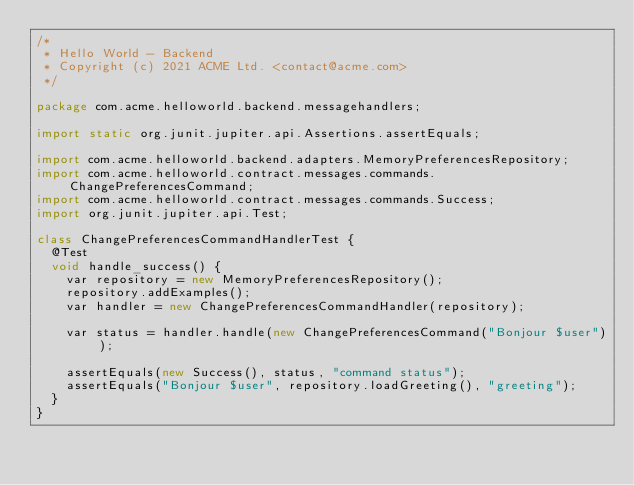<code> <loc_0><loc_0><loc_500><loc_500><_Java_>/*
 * Hello World - Backend
 * Copyright (c) 2021 ACME Ltd. <contact@acme.com>
 */

package com.acme.helloworld.backend.messagehandlers;

import static org.junit.jupiter.api.Assertions.assertEquals;

import com.acme.helloworld.backend.adapters.MemoryPreferencesRepository;
import com.acme.helloworld.contract.messages.commands.ChangePreferencesCommand;
import com.acme.helloworld.contract.messages.commands.Success;
import org.junit.jupiter.api.Test;

class ChangePreferencesCommandHandlerTest {
  @Test
  void handle_success() {
    var repository = new MemoryPreferencesRepository();
    repository.addExamples();
    var handler = new ChangePreferencesCommandHandler(repository);

    var status = handler.handle(new ChangePreferencesCommand("Bonjour $user"));

    assertEquals(new Success(), status, "command status");
    assertEquals("Bonjour $user", repository.loadGreeting(), "greeting");
  }
}
</code> 